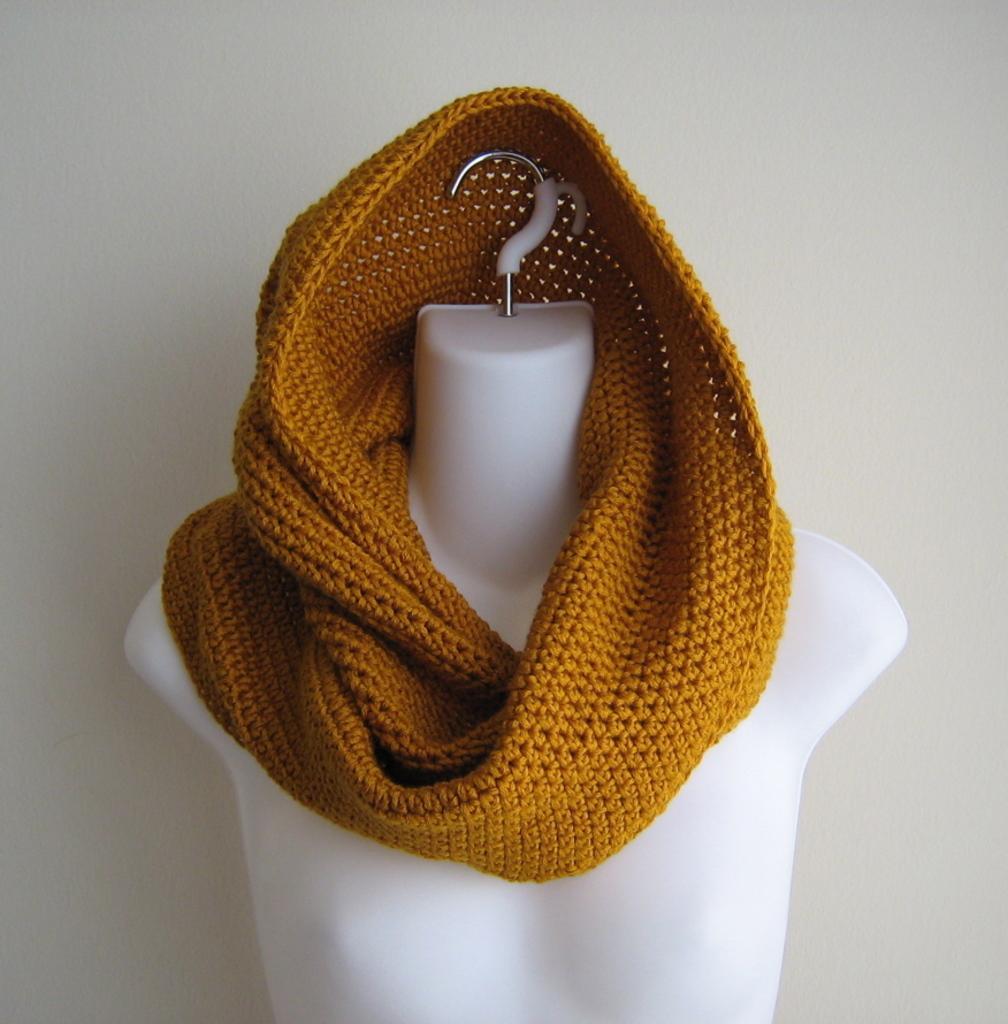Can you describe this image briefly? In this picture I can observe brown color scarf on the mannequin. In the background there is a wall. 